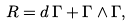<formula> <loc_0><loc_0><loc_500><loc_500>R = d \, \Gamma + \Gamma \wedge \Gamma ,</formula> 